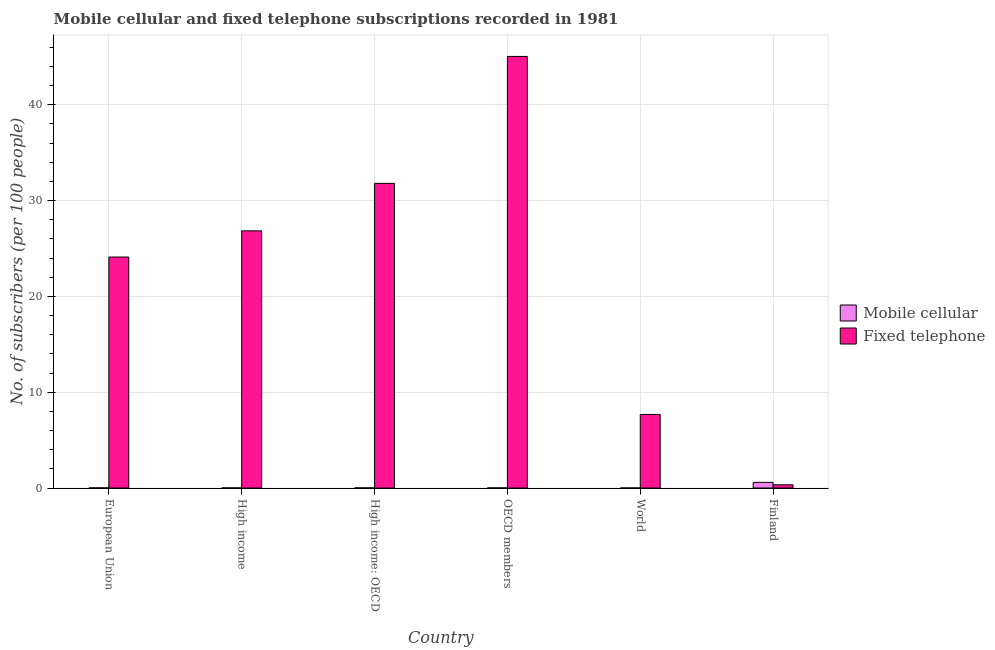How many bars are there on the 4th tick from the left?
Your response must be concise. 2. How many bars are there on the 3rd tick from the right?
Your response must be concise. 2. What is the label of the 3rd group of bars from the left?
Your answer should be very brief. High income: OECD. In how many cases, is the number of bars for a given country not equal to the number of legend labels?
Offer a terse response. 0. What is the number of fixed telephone subscribers in European Union?
Offer a terse response. 24.11. Across all countries, what is the maximum number of fixed telephone subscribers?
Your response must be concise. 45.04. Across all countries, what is the minimum number of mobile cellular subscribers?
Give a very brief answer. 0. What is the total number of fixed telephone subscribers in the graph?
Make the answer very short. 135.8. What is the difference between the number of mobile cellular subscribers in European Union and that in World?
Provide a succinct answer. 0.01. What is the difference between the number of mobile cellular subscribers in World and the number of fixed telephone subscribers in High income?
Your response must be concise. -26.84. What is the average number of mobile cellular subscribers per country?
Ensure brevity in your answer.  0.1. What is the difference between the number of mobile cellular subscribers and number of fixed telephone subscribers in World?
Your answer should be compact. -7.68. What is the ratio of the number of mobile cellular subscribers in European Union to that in High income: OECD?
Provide a succinct answer. 1.06. Is the difference between the number of fixed telephone subscribers in High income and High income: OECD greater than the difference between the number of mobile cellular subscribers in High income and High income: OECD?
Provide a succinct answer. No. What is the difference between the highest and the second highest number of fixed telephone subscribers?
Your answer should be very brief. 13.24. What is the difference between the highest and the lowest number of mobile cellular subscribers?
Provide a succinct answer. 0.59. What does the 1st bar from the left in High income: OECD represents?
Provide a succinct answer. Mobile cellular. What does the 1st bar from the right in OECD members represents?
Give a very brief answer. Fixed telephone. Are all the bars in the graph horizontal?
Offer a terse response. No. How many countries are there in the graph?
Your answer should be compact. 6. Does the graph contain any zero values?
Your answer should be very brief. No. Does the graph contain grids?
Offer a terse response. Yes. Where does the legend appear in the graph?
Give a very brief answer. Center right. How many legend labels are there?
Provide a short and direct response. 2. What is the title of the graph?
Offer a very short reply. Mobile cellular and fixed telephone subscriptions recorded in 1981. What is the label or title of the Y-axis?
Provide a succinct answer. No. of subscribers (per 100 people). What is the No. of subscribers (per 100 people) in Mobile cellular in European Union?
Your answer should be very brief. 0.01. What is the No. of subscribers (per 100 people) of Fixed telephone in European Union?
Your answer should be very brief. 24.11. What is the No. of subscribers (per 100 people) of Mobile cellular in High income?
Keep it short and to the point. 0.01. What is the No. of subscribers (per 100 people) in Fixed telephone in High income?
Provide a short and direct response. 26.84. What is the No. of subscribers (per 100 people) in Mobile cellular in High income: OECD?
Your answer should be very brief. 0.01. What is the No. of subscribers (per 100 people) of Fixed telephone in High income: OECD?
Make the answer very short. 31.8. What is the No. of subscribers (per 100 people) in Mobile cellular in OECD members?
Keep it short and to the point. 0.01. What is the No. of subscribers (per 100 people) in Fixed telephone in OECD members?
Ensure brevity in your answer.  45.04. What is the No. of subscribers (per 100 people) in Mobile cellular in World?
Give a very brief answer. 0. What is the No. of subscribers (per 100 people) of Fixed telephone in World?
Provide a short and direct response. 7.68. What is the No. of subscribers (per 100 people) of Mobile cellular in Finland?
Your answer should be very brief. 0.59. What is the No. of subscribers (per 100 people) in Fixed telephone in Finland?
Keep it short and to the point. 0.33. Across all countries, what is the maximum No. of subscribers (per 100 people) of Mobile cellular?
Your answer should be very brief. 0.59. Across all countries, what is the maximum No. of subscribers (per 100 people) of Fixed telephone?
Provide a succinct answer. 45.04. Across all countries, what is the minimum No. of subscribers (per 100 people) of Mobile cellular?
Provide a short and direct response. 0. Across all countries, what is the minimum No. of subscribers (per 100 people) of Fixed telephone?
Offer a terse response. 0.33. What is the total No. of subscribers (per 100 people) in Mobile cellular in the graph?
Offer a terse response. 0.63. What is the total No. of subscribers (per 100 people) in Fixed telephone in the graph?
Offer a very short reply. 135.8. What is the difference between the No. of subscribers (per 100 people) in Mobile cellular in European Union and that in High income?
Provide a short and direct response. 0. What is the difference between the No. of subscribers (per 100 people) in Fixed telephone in European Union and that in High income?
Offer a very short reply. -2.73. What is the difference between the No. of subscribers (per 100 people) of Mobile cellular in European Union and that in High income: OECD?
Provide a succinct answer. 0. What is the difference between the No. of subscribers (per 100 people) in Fixed telephone in European Union and that in High income: OECD?
Ensure brevity in your answer.  -7.69. What is the difference between the No. of subscribers (per 100 people) of Mobile cellular in European Union and that in OECD members?
Offer a very short reply. 0. What is the difference between the No. of subscribers (per 100 people) of Fixed telephone in European Union and that in OECD members?
Ensure brevity in your answer.  -20.93. What is the difference between the No. of subscribers (per 100 people) of Mobile cellular in European Union and that in World?
Provide a short and direct response. 0.01. What is the difference between the No. of subscribers (per 100 people) of Fixed telephone in European Union and that in World?
Provide a succinct answer. 16.43. What is the difference between the No. of subscribers (per 100 people) of Mobile cellular in European Union and that in Finland?
Your answer should be very brief. -0.58. What is the difference between the No. of subscribers (per 100 people) of Fixed telephone in European Union and that in Finland?
Your answer should be very brief. 23.77. What is the difference between the No. of subscribers (per 100 people) in Mobile cellular in High income and that in High income: OECD?
Offer a very short reply. -0. What is the difference between the No. of subscribers (per 100 people) in Fixed telephone in High income and that in High income: OECD?
Give a very brief answer. -4.96. What is the difference between the No. of subscribers (per 100 people) in Mobile cellular in High income and that in OECD members?
Ensure brevity in your answer.  -0. What is the difference between the No. of subscribers (per 100 people) in Fixed telephone in High income and that in OECD members?
Keep it short and to the point. -18.2. What is the difference between the No. of subscribers (per 100 people) of Mobile cellular in High income and that in World?
Offer a terse response. 0.01. What is the difference between the No. of subscribers (per 100 people) in Fixed telephone in High income and that in World?
Give a very brief answer. 19.16. What is the difference between the No. of subscribers (per 100 people) of Mobile cellular in High income and that in Finland?
Provide a short and direct response. -0.58. What is the difference between the No. of subscribers (per 100 people) in Fixed telephone in High income and that in Finland?
Your response must be concise. 26.51. What is the difference between the No. of subscribers (per 100 people) of Mobile cellular in High income: OECD and that in OECD members?
Offer a very short reply. 0. What is the difference between the No. of subscribers (per 100 people) of Fixed telephone in High income: OECD and that in OECD members?
Give a very brief answer. -13.24. What is the difference between the No. of subscribers (per 100 people) in Mobile cellular in High income: OECD and that in World?
Your answer should be very brief. 0.01. What is the difference between the No. of subscribers (per 100 people) of Fixed telephone in High income: OECD and that in World?
Give a very brief answer. 24.12. What is the difference between the No. of subscribers (per 100 people) in Mobile cellular in High income: OECD and that in Finland?
Provide a short and direct response. -0.58. What is the difference between the No. of subscribers (per 100 people) of Fixed telephone in High income: OECD and that in Finland?
Offer a terse response. 31.46. What is the difference between the No. of subscribers (per 100 people) in Mobile cellular in OECD members and that in World?
Your answer should be very brief. 0.01. What is the difference between the No. of subscribers (per 100 people) in Fixed telephone in OECD members and that in World?
Your answer should be very brief. 37.36. What is the difference between the No. of subscribers (per 100 people) of Mobile cellular in OECD members and that in Finland?
Offer a terse response. -0.58. What is the difference between the No. of subscribers (per 100 people) of Fixed telephone in OECD members and that in Finland?
Keep it short and to the point. 44.71. What is the difference between the No. of subscribers (per 100 people) in Mobile cellular in World and that in Finland?
Your answer should be compact. -0.59. What is the difference between the No. of subscribers (per 100 people) in Fixed telephone in World and that in Finland?
Ensure brevity in your answer.  7.34. What is the difference between the No. of subscribers (per 100 people) in Mobile cellular in European Union and the No. of subscribers (per 100 people) in Fixed telephone in High income?
Ensure brevity in your answer.  -26.83. What is the difference between the No. of subscribers (per 100 people) of Mobile cellular in European Union and the No. of subscribers (per 100 people) of Fixed telephone in High income: OECD?
Provide a short and direct response. -31.79. What is the difference between the No. of subscribers (per 100 people) in Mobile cellular in European Union and the No. of subscribers (per 100 people) in Fixed telephone in OECD members?
Your response must be concise. -45.03. What is the difference between the No. of subscribers (per 100 people) in Mobile cellular in European Union and the No. of subscribers (per 100 people) in Fixed telephone in World?
Give a very brief answer. -7.67. What is the difference between the No. of subscribers (per 100 people) of Mobile cellular in European Union and the No. of subscribers (per 100 people) of Fixed telephone in Finland?
Offer a very short reply. -0.32. What is the difference between the No. of subscribers (per 100 people) in Mobile cellular in High income and the No. of subscribers (per 100 people) in Fixed telephone in High income: OECD?
Give a very brief answer. -31.79. What is the difference between the No. of subscribers (per 100 people) of Mobile cellular in High income and the No. of subscribers (per 100 people) of Fixed telephone in OECD members?
Provide a succinct answer. -45.04. What is the difference between the No. of subscribers (per 100 people) of Mobile cellular in High income and the No. of subscribers (per 100 people) of Fixed telephone in World?
Make the answer very short. -7.67. What is the difference between the No. of subscribers (per 100 people) of Mobile cellular in High income and the No. of subscribers (per 100 people) of Fixed telephone in Finland?
Provide a short and direct response. -0.33. What is the difference between the No. of subscribers (per 100 people) of Mobile cellular in High income: OECD and the No. of subscribers (per 100 people) of Fixed telephone in OECD members?
Offer a terse response. -45.03. What is the difference between the No. of subscribers (per 100 people) in Mobile cellular in High income: OECD and the No. of subscribers (per 100 people) in Fixed telephone in World?
Ensure brevity in your answer.  -7.67. What is the difference between the No. of subscribers (per 100 people) of Mobile cellular in High income: OECD and the No. of subscribers (per 100 people) of Fixed telephone in Finland?
Give a very brief answer. -0.32. What is the difference between the No. of subscribers (per 100 people) of Mobile cellular in OECD members and the No. of subscribers (per 100 people) of Fixed telephone in World?
Offer a very short reply. -7.67. What is the difference between the No. of subscribers (per 100 people) in Mobile cellular in OECD members and the No. of subscribers (per 100 people) in Fixed telephone in Finland?
Your answer should be very brief. -0.33. What is the difference between the No. of subscribers (per 100 people) of Mobile cellular in World and the No. of subscribers (per 100 people) of Fixed telephone in Finland?
Ensure brevity in your answer.  -0.33. What is the average No. of subscribers (per 100 people) of Mobile cellular per country?
Make the answer very short. 0.1. What is the average No. of subscribers (per 100 people) of Fixed telephone per country?
Make the answer very short. 22.63. What is the difference between the No. of subscribers (per 100 people) in Mobile cellular and No. of subscribers (per 100 people) in Fixed telephone in European Union?
Offer a very short reply. -24.1. What is the difference between the No. of subscribers (per 100 people) of Mobile cellular and No. of subscribers (per 100 people) of Fixed telephone in High income?
Provide a short and direct response. -26.83. What is the difference between the No. of subscribers (per 100 people) in Mobile cellular and No. of subscribers (per 100 people) in Fixed telephone in High income: OECD?
Give a very brief answer. -31.79. What is the difference between the No. of subscribers (per 100 people) of Mobile cellular and No. of subscribers (per 100 people) of Fixed telephone in OECD members?
Make the answer very short. -45.03. What is the difference between the No. of subscribers (per 100 people) of Mobile cellular and No. of subscribers (per 100 people) of Fixed telephone in World?
Give a very brief answer. -7.68. What is the difference between the No. of subscribers (per 100 people) in Mobile cellular and No. of subscribers (per 100 people) in Fixed telephone in Finland?
Give a very brief answer. 0.26. What is the ratio of the No. of subscribers (per 100 people) of Mobile cellular in European Union to that in High income?
Provide a short and direct response. 1.44. What is the ratio of the No. of subscribers (per 100 people) of Fixed telephone in European Union to that in High income?
Your answer should be compact. 0.9. What is the ratio of the No. of subscribers (per 100 people) in Mobile cellular in European Union to that in High income: OECD?
Offer a very short reply. 1.06. What is the ratio of the No. of subscribers (per 100 people) in Fixed telephone in European Union to that in High income: OECD?
Your response must be concise. 0.76. What is the ratio of the No. of subscribers (per 100 people) in Mobile cellular in European Union to that in OECD members?
Your answer should be compact. 1.25. What is the ratio of the No. of subscribers (per 100 people) of Fixed telephone in European Union to that in OECD members?
Offer a terse response. 0.54. What is the ratio of the No. of subscribers (per 100 people) in Mobile cellular in European Union to that in World?
Offer a very short reply. 7.02. What is the ratio of the No. of subscribers (per 100 people) in Fixed telephone in European Union to that in World?
Ensure brevity in your answer.  3.14. What is the ratio of the No. of subscribers (per 100 people) of Mobile cellular in European Union to that in Finland?
Provide a succinct answer. 0.02. What is the ratio of the No. of subscribers (per 100 people) in Fixed telephone in European Union to that in Finland?
Make the answer very short. 72.24. What is the ratio of the No. of subscribers (per 100 people) of Mobile cellular in High income to that in High income: OECD?
Your answer should be compact. 0.73. What is the ratio of the No. of subscribers (per 100 people) in Fixed telephone in High income to that in High income: OECD?
Offer a very short reply. 0.84. What is the ratio of the No. of subscribers (per 100 people) of Mobile cellular in High income to that in OECD members?
Keep it short and to the point. 0.87. What is the ratio of the No. of subscribers (per 100 people) of Fixed telephone in High income to that in OECD members?
Provide a short and direct response. 0.6. What is the ratio of the No. of subscribers (per 100 people) of Mobile cellular in High income to that in World?
Give a very brief answer. 4.87. What is the ratio of the No. of subscribers (per 100 people) in Fixed telephone in High income to that in World?
Provide a short and direct response. 3.5. What is the ratio of the No. of subscribers (per 100 people) in Mobile cellular in High income to that in Finland?
Make the answer very short. 0.01. What is the ratio of the No. of subscribers (per 100 people) of Fixed telephone in High income to that in Finland?
Provide a succinct answer. 80.43. What is the ratio of the No. of subscribers (per 100 people) in Mobile cellular in High income: OECD to that in OECD members?
Provide a short and direct response. 1.18. What is the ratio of the No. of subscribers (per 100 people) in Fixed telephone in High income: OECD to that in OECD members?
Keep it short and to the point. 0.71. What is the ratio of the No. of subscribers (per 100 people) in Mobile cellular in High income: OECD to that in World?
Provide a succinct answer. 6.65. What is the ratio of the No. of subscribers (per 100 people) in Fixed telephone in High income: OECD to that in World?
Your answer should be compact. 4.14. What is the ratio of the No. of subscribers (per 100 people) of Mobile cellular in High income: OECD to that in Finland?
Make the answer very short. 0.02. What is the ratio of the No. of subscribers (per 100 people) in Fixed telephone in High income: OECD to that in Finland?
Keep it short and to the point. 95.29. What is the ratio of the No. of subscribers (per 100 people) in Mobile cellular in OECD members to that in World?
Provide a succinct answer. 5.62. What is the ratio of the No. of subscribers (per 100 people) in Fixed telephone in OECD members to that in World?
Ensure brevity in your answer.  5.87. What is the ratio of the No. of subscribers (per 100 people) in Mobile cellular in OECD members to that in Finland?
Your answer should be very brief. 0.01. What is the ratio of the No. of subscribers (per 100 people) of Fixed telephone in OECD members to that in Finland?
Provide a succinct answer. 134.97. What is the ratio of the No. of subscribers (per 100 people) of Mobile cellular in World to that in Finland?
Keep it short and to the point. 0. What is the ratio of the No. of subscribers (per 100 people) in Fixed telephone in World to that in Finland?
Offer a very short reply. 23.01. What is the difference between the highest and the second highest No. of subscribers (per 100 people) in Mobile cellular?
Your answer should be very brief. 0.58. What is the difference between the highest and the second highest No. of subscribers (per 100 people) in Fixed telephone?
Offer a very short reply. 13.24. What is the difference between the highest and the lowest No. of subscribers (per 100 people) in Mobile cellular?
Ensure brevity in your answer.  0.59. What is the difference between the highest and the lowest No. of subscribers (per 100 people) in Fixed telephone?
Keep it short and to the point. 44.71. 